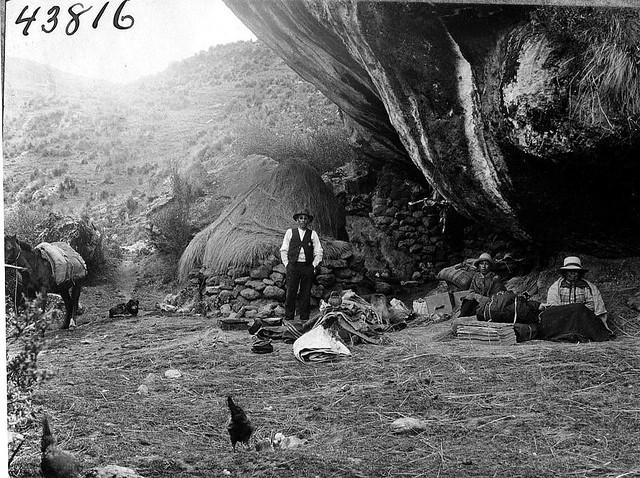How many people are in this picture?
Give a very brief answer. 3. What are the numbers on the picture?
Write a very short answer. 43816. How many chickens do you see in the picture?
Short answer required. 2. 